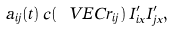<formula> <loc_0><loc_0><loc_500><loc_500>a _ { i j } ( t ) \, c ( \ V E C { r } _ { i j } ) \, I _ { i x } ^ { \prime } I _ { j x } ^ { \prime } ,</formula> 